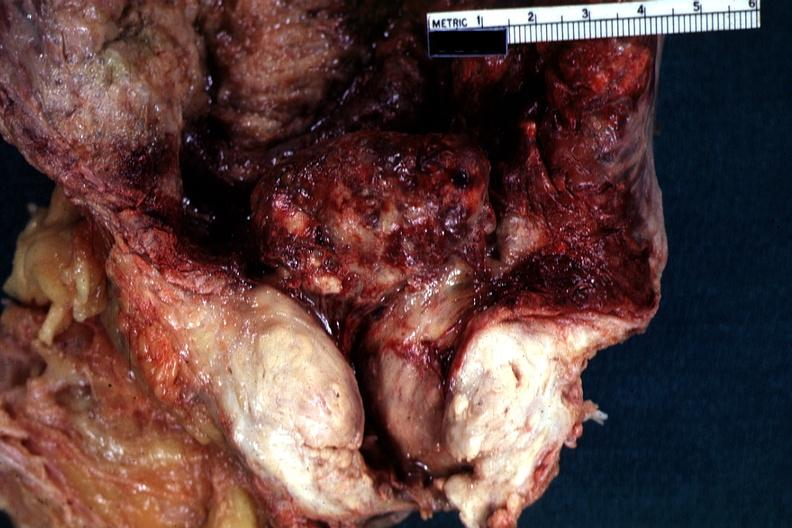what does this image show?
Answer the question using a single word or phrase. Close-up view of large median bar type lesion with severe cystitis 